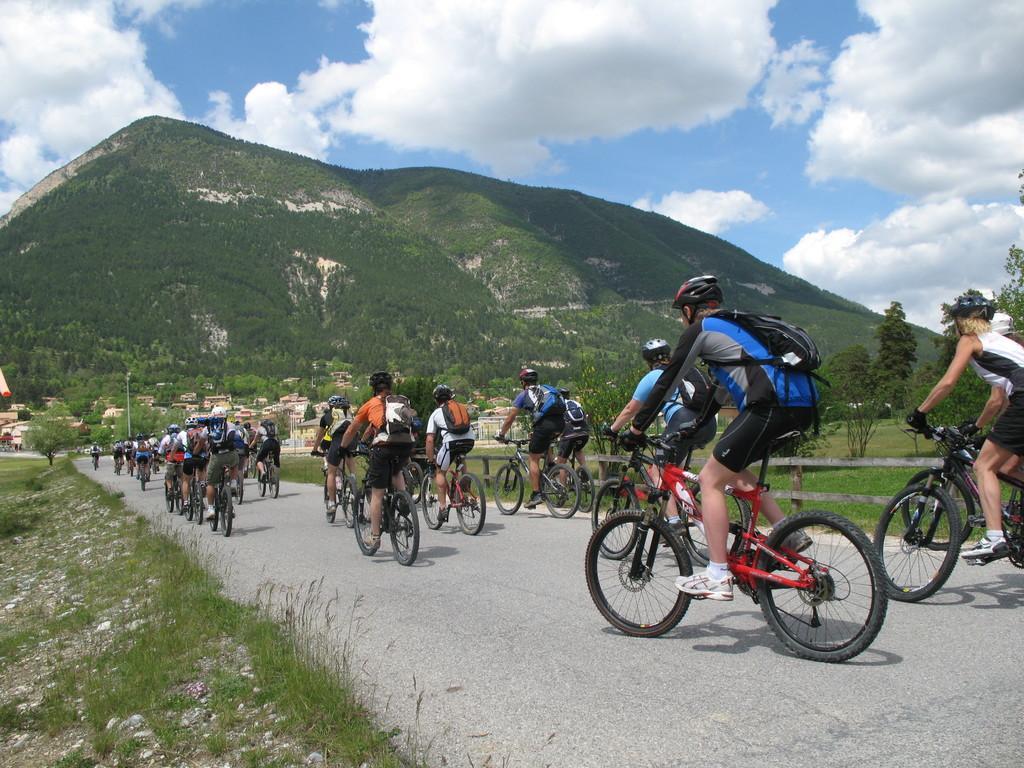Describe this image in one or two sentences. There are groups of people riding bicycles on the road. This is the grass. This looks like a mountain. I think these are the houses and the trees. I can see the clouds in the sky. 